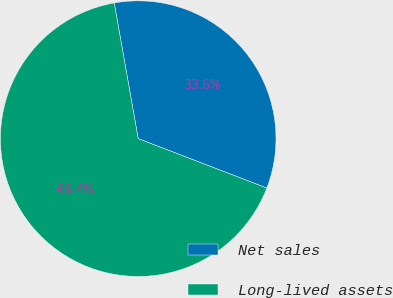Convert chart. <chart><loc_0><loc_0><loc_500><loc_500><pie_chart><fcel>Net sales<fcel>Long-lived assets<nl><fcel>33.62%<fcel>66.38%<nl></chart> 